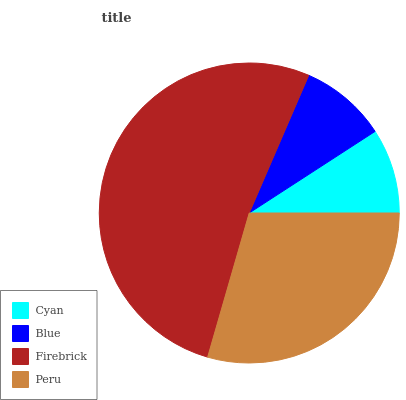Is Cyan the minimum?
Answer yes or no. Yes. Is Firebrick the maximum?
Answer yes or no. Yes. Is Blue the minimum?
Answer yes or no. No. Is Blue the maximum?
Answer yes or no. No. Is Blue greater than Cyan?
Answer yes or no. Yes. Is Cyan less than Blue?
Answer yes or no. Yes. Is Cyan greater than Blue?
Answer yes or no. No. Is Blue less than Cyan?
Answer yes or no. No. Is Peru the high median?
Answer yes or no. Yes. Is Blue the low median?
Answer yes or no. Yes. Is Blue the high median?
Answer yes or no. No. Is Firebrick the low median?
Answer yes or no. No. 